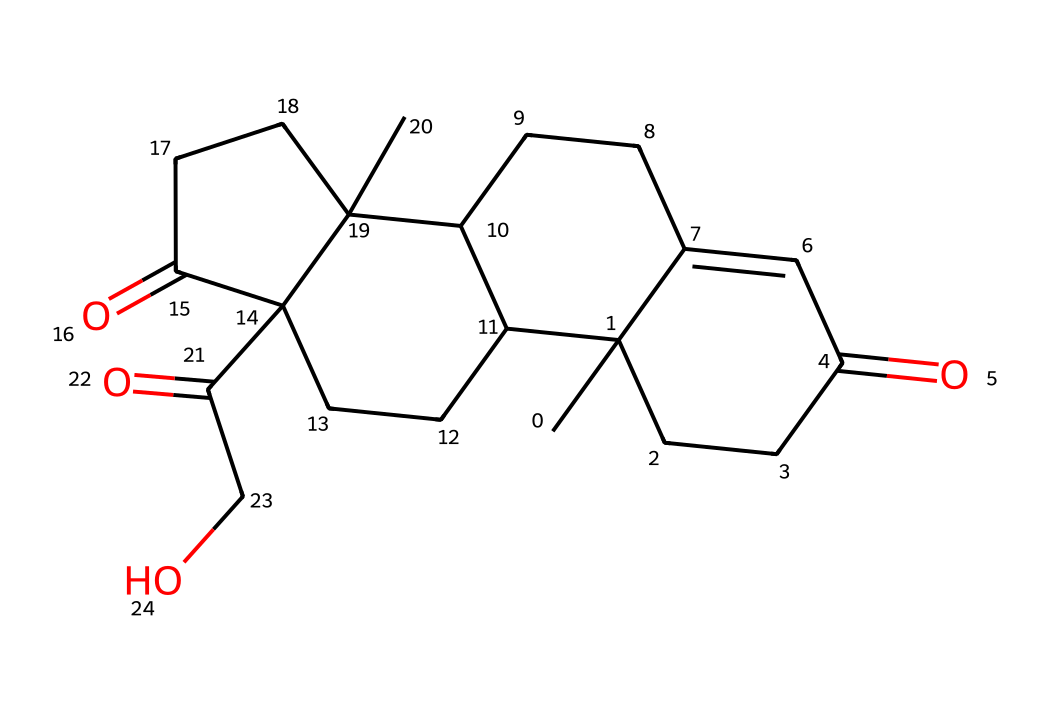What is the molecular formula of cortisone? To determine the molecular formula, we count the number of each type of atom present in the SMILES representation. The representation indicates there are 21 carbon atoms (C), 30 hydrogen atoms (H), and 5 oxygen atoms (O). Thus, the molecular formula is C21H30O5.
Answer: C21H30O5 How many ketone functional groups are present in cortisone? By analyzing the structure for ketone groups (which are characterized by a carbonyl group, C=O, attached to a carbon), we identify three distinct carbonyls in the structure of cortisone. Therefore, there are three ketone functional groups.
Answer: 3 What is the total number of rings in the cortisone molecule? The structure of cortisone contains four interconnected rings. This can be determined by visually analyzing the cyclic components in the SMILES structure where multiple cyclic structures are indicated. Thus, the total number of rings is four.
Answer: 4 Which atom type indicates the presence of a ketone in cortisone? The presence of a ketone is indicated by the carbon atom that has a double bond with oxygen (C=O) in the structure. This is crucial to identify the functional groups present in the molecule. Therefore, the atom type that indicates a ketone is carbon with an attached oxygen in a carbonyl configuration.
Answer: carbon What is the role of cortisone in stress management? Cortisone behaves as an anti-inflammatory agent, which is important in stress management as it helps alleviate physical inflammation caused by stress-related reactions. Thus, cortisone's primary role in stress management is to reduce inflammation.
Answer: anti-inflammatory 